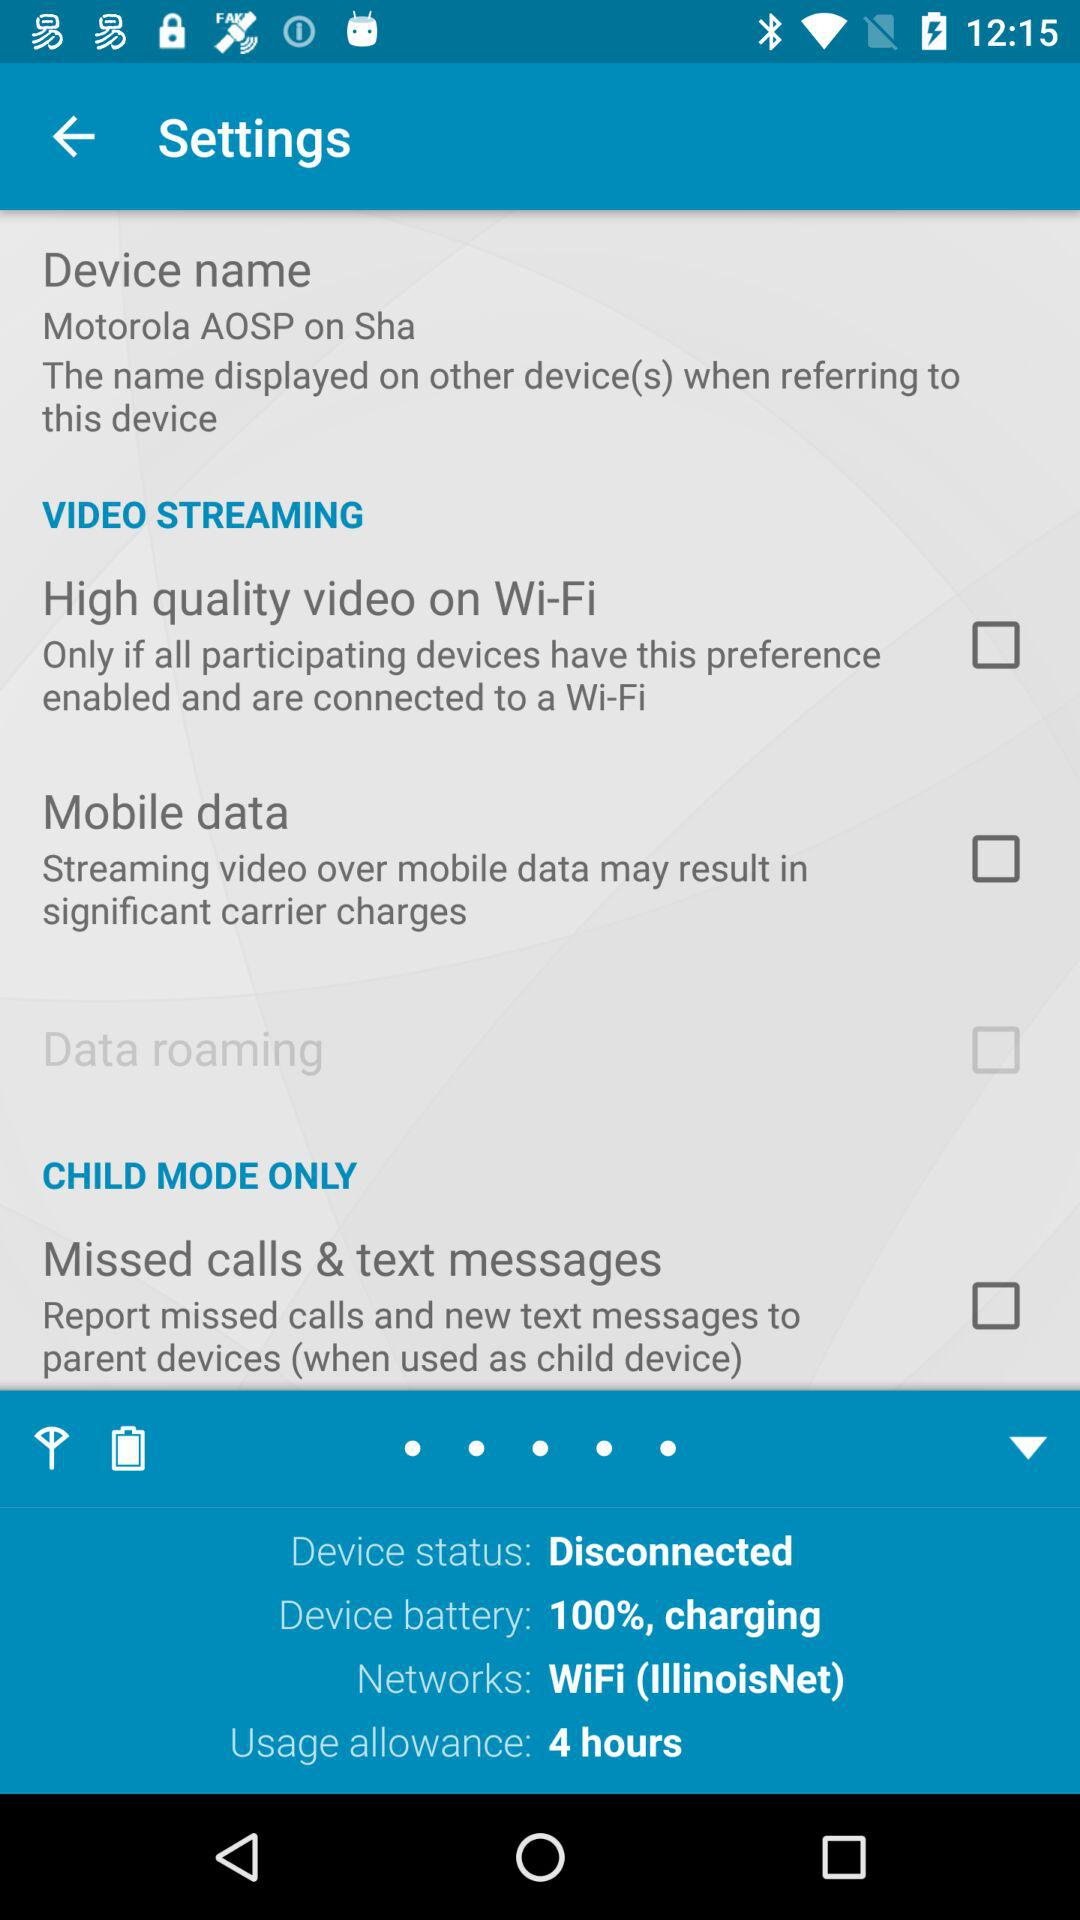How much duration is of the "Usage allowance"? The duration is 4 hours. 